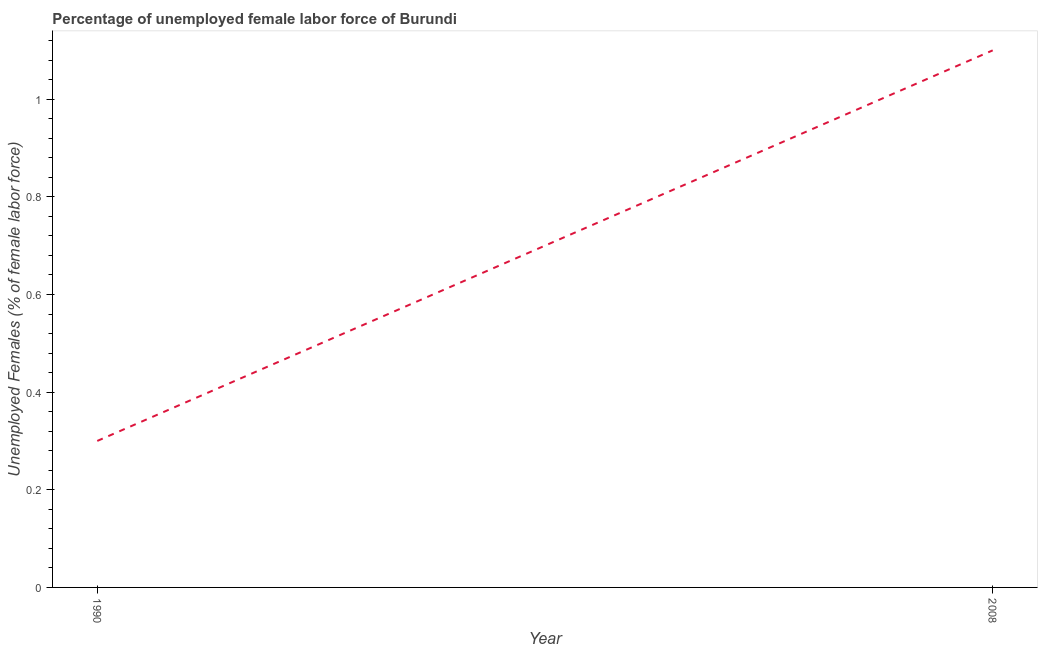What is the total unemployed female labour force in 2008?
Provide a succinct answer. 1.1. Across all years, what is the maximum total unemployed female labour force?
Your response must be concise. 1.1. Across all years, what is the minimum total unemployed female labour force?
Make the answer very short. 0.3. In which year was the total unemployed female labour force minimum?
Your response must be concise. 1990. What is the sum of the total unemployed female labour force?
Give a very brief answer. 1.4. What is the difference between the total unemployed female labour force in 1990 and 2008?
Your answer should be compact. -0.8. What is the average total unemployed female labour force per year?
Keep it short and to the point. 0.7. What is the median total unemployed female labour force?
Give a very brief answer. 0.7. What is the ratio of the total unemployed female labour force in 1990 to that in 2008?
Your answer should be compact. 0.27. Is the total unemployed female labour force in 1990 less than that in 2008?
Your answer should be very brief. Yes. What is the difference between two consecutive major ticks on the Y-axis?
Your response must be concise. 0.2. Are the values on the major ticks of Y-axis written in scientific E-notation?
Make the answer very short. No. Does the graph contain grids?
Keep it short and to the point. No. What is the title of the graph?
Ensure brevity in your answer.  Percentage of unemployed female labor force of Burundi. What is the label or title of the X-axis?
Keep it short and to the point. Year. What is the label or title of the Y-axis?
Offer a very short reply. Unemployed Females (% of female labor force). What is the Unemployed Females (% of female labor force) of 1990?
Offer a very short reply. 0.3. What is the Unemployed Females (% of female labor force) in 2008?
Your answer should be very brief. 1.1. What is the ratio of the Unemployed Females (% of female labor force) in 1990 to that in 2008?
Your answer should be compact. 0.27. 